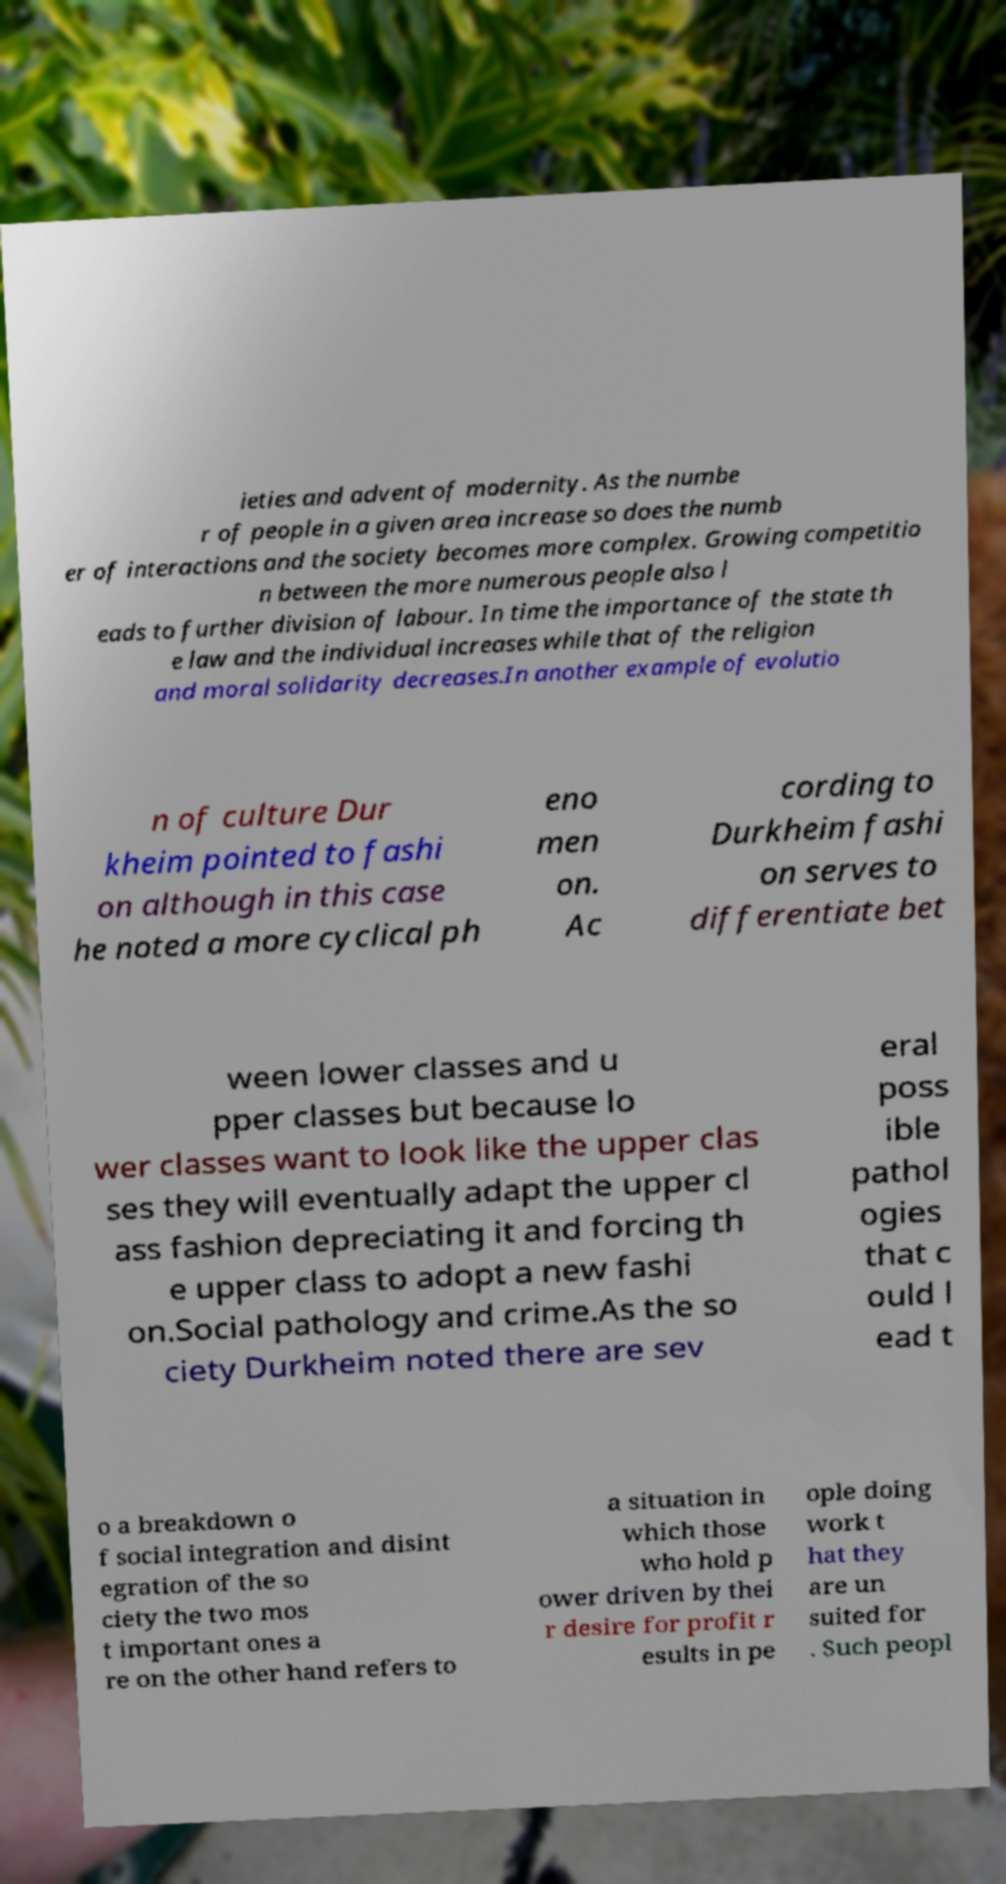For documentation purposes, I need the text within this image transcribed. Could you provide that? ieties and advent of modernity. As the numbe r of people in a given area increase so does the numb er of interactions and the society becomes more complex. Growing competitio n between the more numerous people also l eads to further division of labour. In time the importance of the state th e law and the individual increases while that of the religion and moral solidarity decreases.In another example of evolutio n of culture Dur kheim pointed to fashi on although in this case he noted a more cyclical ph eno men on. Ac cording to Durkheim fashi on serves to differentiate bet ween lower classes and u pper classes but because lo wer classes want to look like the upper clas ses they will eventually adapt the upper cl ass fashion depreciating it and forcing th e upper class to adopt a new fashi on.Social pathology and crime.As the so ciety Durkheim noted there are sev eral poss ible pathol ogies that c ould l ead t o a breakdown o f social integration and disint egration of the so ciety the two mos t important ones a re on the other hand refers to a situation in which those who hold p ower driven by thei r desire for profit r esults in pe ople doing work t hat they are un suited for . Such peopl 